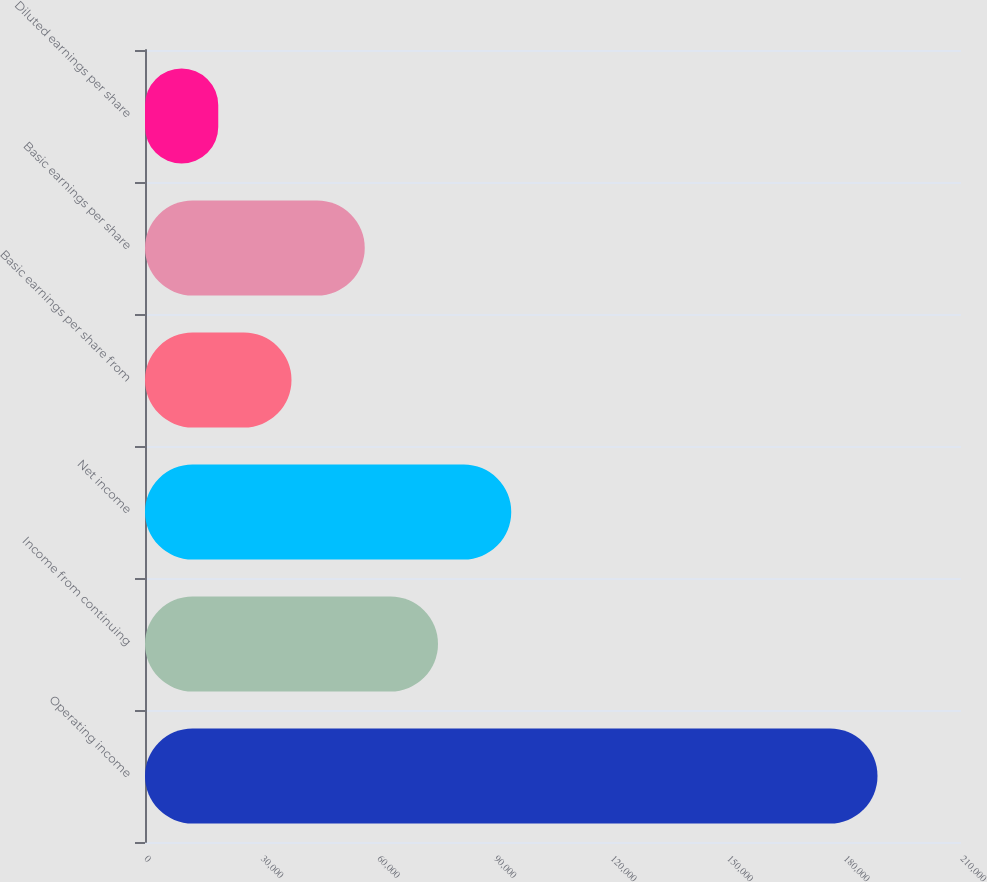Convert chart. <chart><loc_0><loc_0><loc_500><loc_500><bar_chart><fcel>Operating income<fcel>Income from continuing<fcel>Net income<fcel>Basic earnings per share from<fcel>Basic earnings per share<fcel>Diluted earnings per share<nl><fcel>188511<fcel>75404.8<fcel>94255.9<fcel>37702.8<fcel>56553.8<fcel>18851.7<nl></chart> 